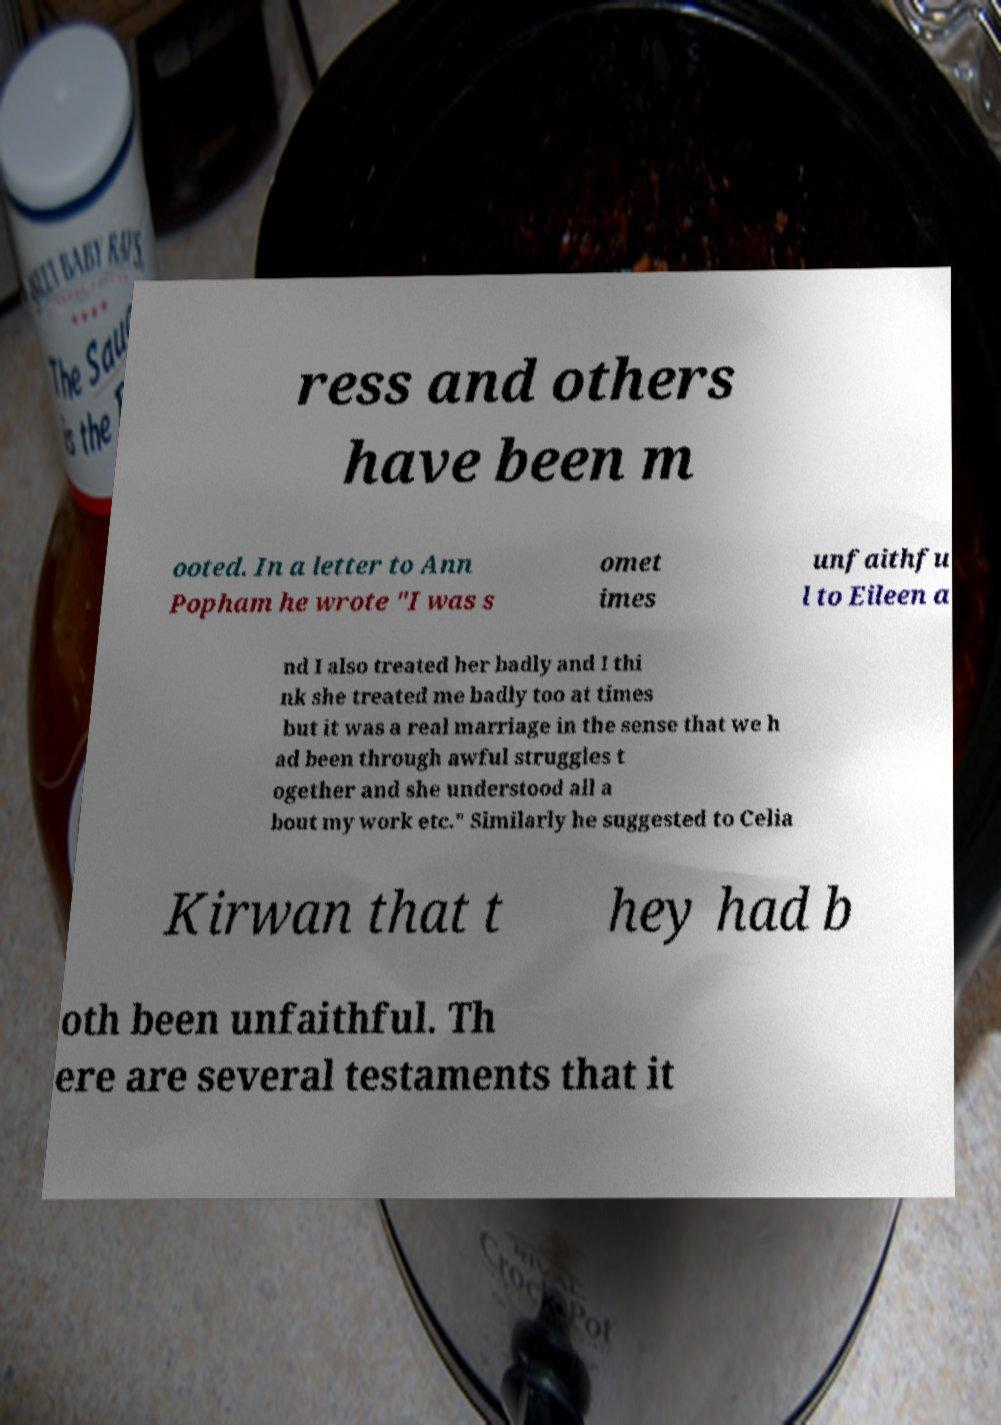Can you accurately transcribe the text from the provided image for me? ress and others have been m ooted. In a letter to Ann Popham he wrote "I was s omet imes unfaithfu l to Eileen a nd I also treated her badly and I thi nk she treated me badly too at times but it was a real marriage in the sense that we h ad been through awful struggles t ogether and she understood all a bout my work etc." Similarly he suggested to Celia Kirwan that t hey had b oth been unfaithful. Th ere are several testaments that it 